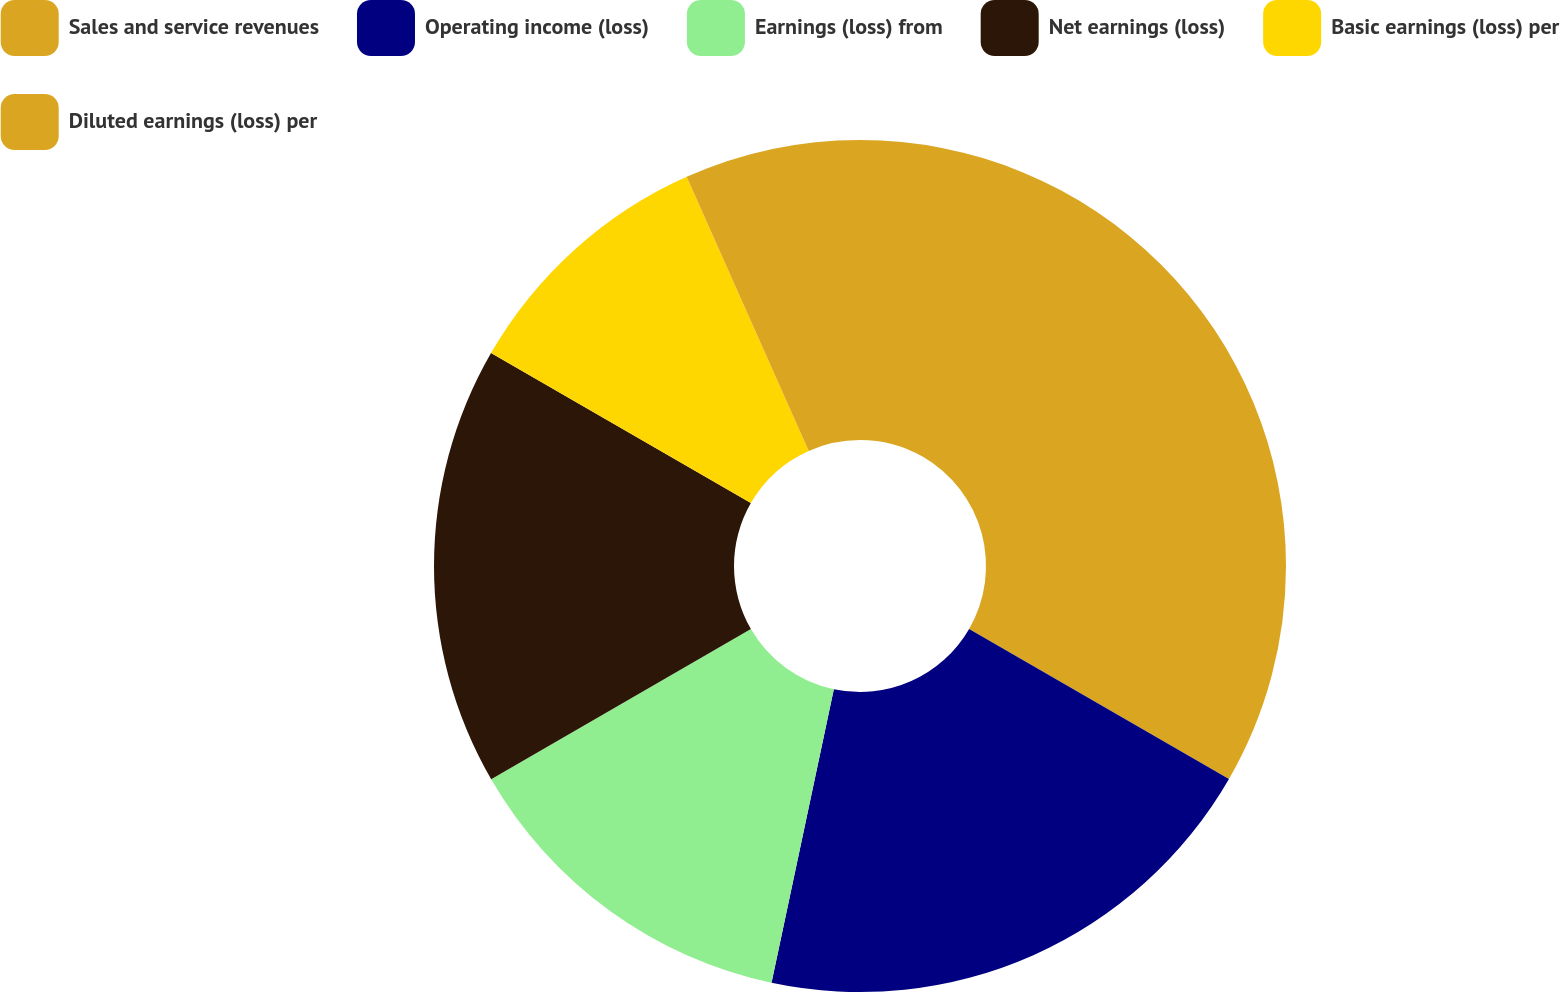<chart> <loc_0><loc_0><loc_500><loc_500><pie_chart><fcel>Sales and service revenues<fcel>Operating income (loss)<fcel>Earnings (loss) from<fcel>Net earnings (loss)<fcel>Basic earnings (loss) per<fcel>Diluted earnings (loss) per<nl><fcel>33.33%<fcel>20.0%<fcel>13.33%<fcel>16.67%<fcel>10.0%<fcel>6.67%<nl></chart> 